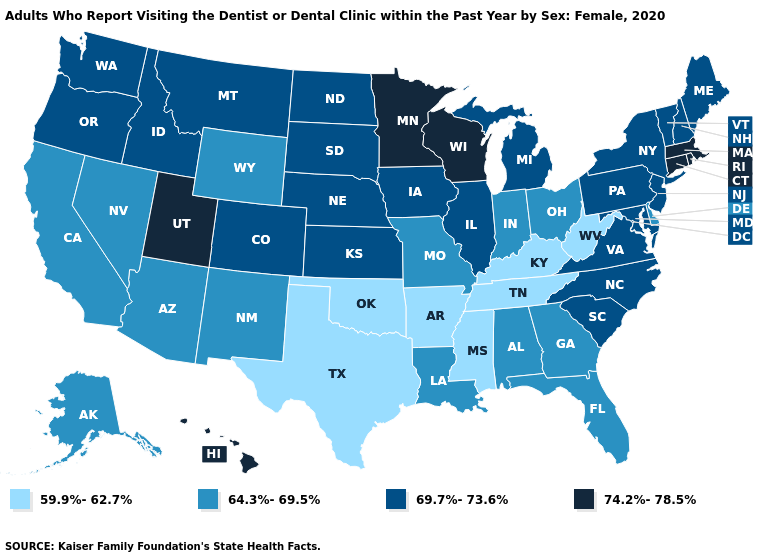Does Massachusetts have the lowest value in the USA?
Quick response, please. No. Does Kansas have a lower value than Massachusetts?
Give a very brief answer. Yes. What is the value of South Carolina?
Be succinct. 69.7%-73.6%. Does Oregon have the lowest value in the USA?
Be succinct. No. What is the value of Wyoming?
Short answer required. 64.3%-69.5%. What is the value of Pennsylvania?
Quick response, please. 69.7%-73.6%. What is the value of Tennessee?
Be succinct. 59.9%-62.7%. Among the states that border Nevada , which have the highest value?
Short answer required. Utah. Does Tennessee have the lowest value in the USA?
Quick response, please. Yes. Is the legend a continuous bar?
Short answer required. No. What is the highest value in the USA?
Give a very brief answer. 74.2%-78.5%. Name the states that have a value in the range 59.9%-62.7%?
Quick response, please. Arkansas, Kentucky, Mississippi, Oklahoma, Tennessee, Texas, West Virginia. Does Michigan have the same value as New Hampshire?
Be succinct. Yes. How many symbols are there in the legend?
Be succinct. 4. What is the highest value in the South ?
Keep it brief. 69.7%-73.6%. 